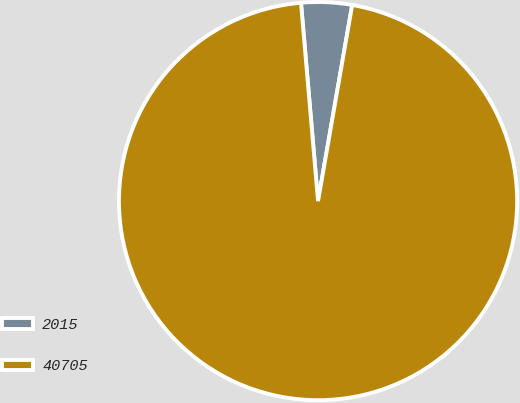Convert chart. <chart><loc_0><loc_0><loc_500><loc_500><pie_chart><fcel>2015<fcel>40705<nl><fcel>4.11%<fcel>95.89%<nl></chart> 